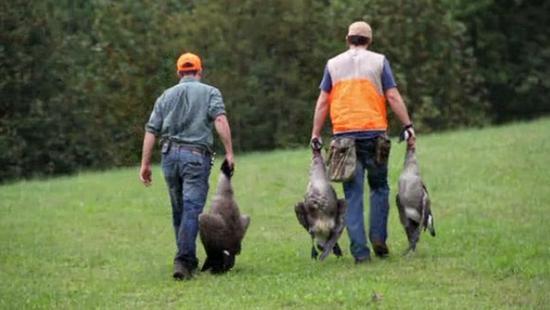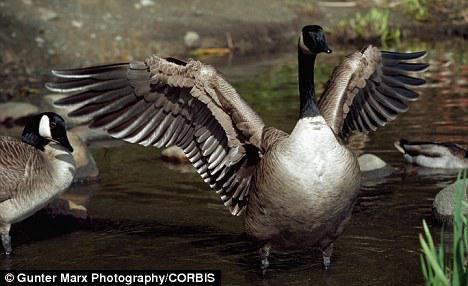The first image is the image on the left, the second image is the image on the right. Assess this claim about the two images: "There are at least two baby geese.". Correct or not? Answer yes or no. No. The first image is the image on the left, the second image is the image on the right. Analyze the images presented: Is the assertion "There are a handful of goslings (baby geese) in the left image." valid? Answer yes or no. No. 